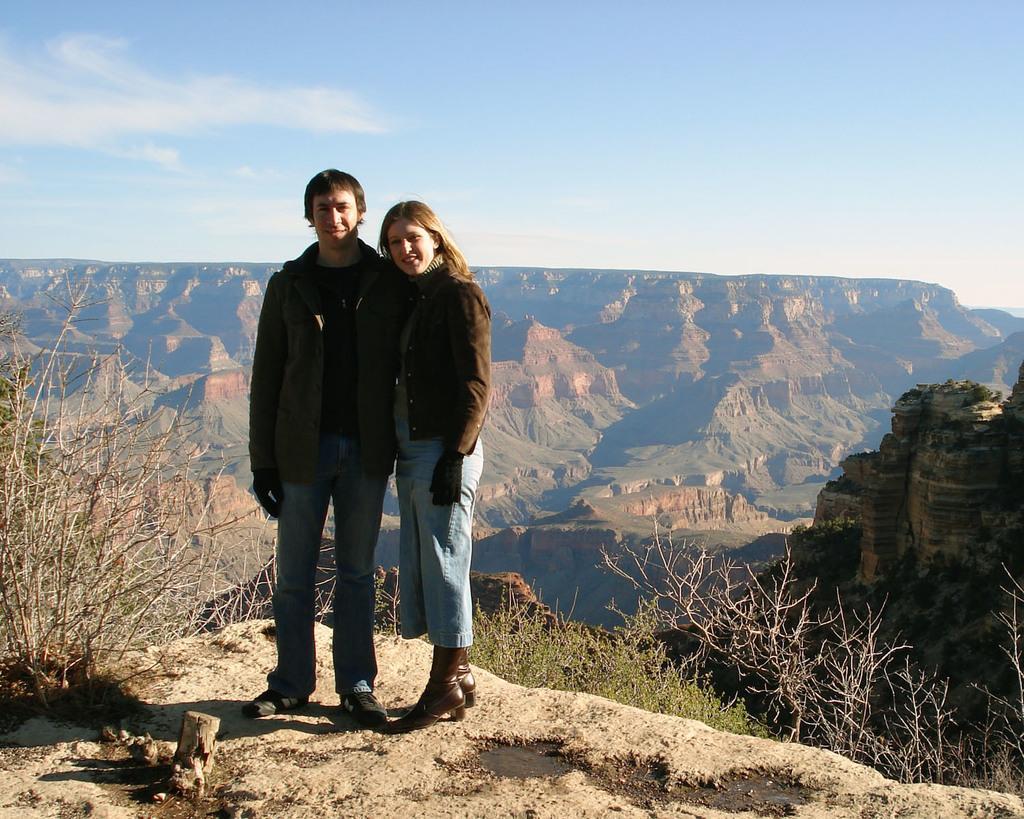Please provide a concise description of this image. In this image we can see a man and a woman standing on the ground. We can also see some dried branches, grass and plants. On the backside we can see the mountains and the sky which looks cloudy. 